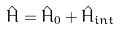Convert formula to latex. <formula><loc_0><loc_0><loc_500><loc_500>\hat { H } = \hat { H } _ { 0 } + \hat { H } _ { i n t }</formula> 